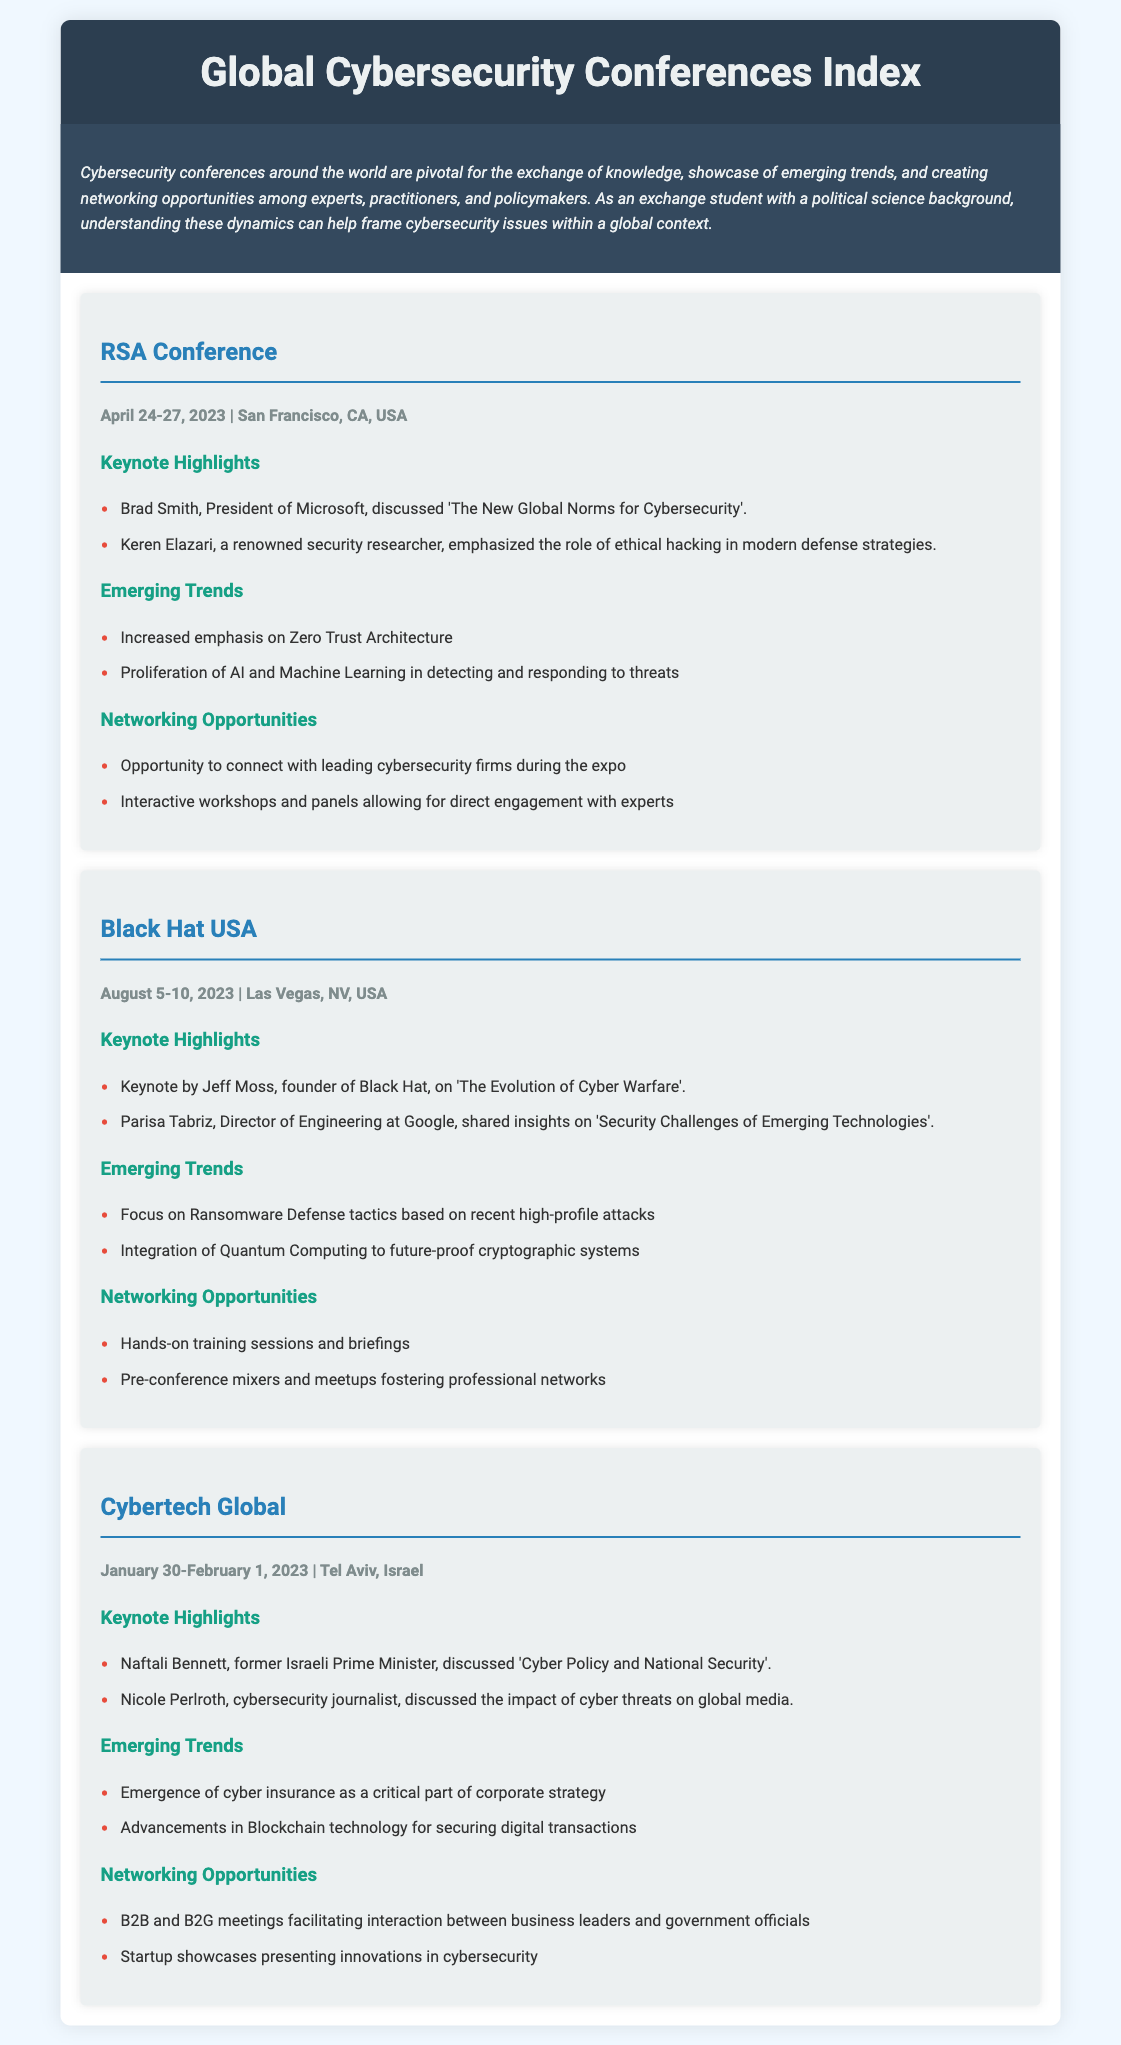What is the date of the RSA Conference? The date of the RSA Conference, as stated in the document, is April 24-27, 2023.
Answer: April 24-27, 2023 Who discussed 'Cyber Policy and National Security' at Cybertech Global? Naftali Bennett, the former Israeli Prime Minister, discussed 'Cyber Policy and National Security' at Cybertech Global.
Answer: Naftali Bennett Which conference took place in Tel Aviv, Israel? The document specifies that the Cybertech Global conference was held in Tel Aviv, Israel.
Answer: Cybertech Global What emerging trend was highlighted at Black Hat USA? The document mentions a focus on Ransomware Defense tactics based on recent high-profile attacks as an emerging trend at Black Hat USA.
Answer: Ransomware Defense tactics What type of networking opportunities were available at the RSA Conference? The document lists opportunities including connecting with leading cybersecurity firms and interacting with experts during workshops at the RSA Conference.
Answer: Connect with leading cybersecurity firms Who emphasized the role of ethical hacking at the RSA Conference? Keren Elazari emphasized the role of ethical hacking in modern defense strategies at the RSA Conference.
Answer: Keren Elazari How many keynote highlights are listed for the Black Hat USA conference? The document presents two keynote highlights for Black Hat USA: one by Jeff Moss and another by Parisa Tabriz.
Answer: Two What was discussed by Nicole Perlroth at Cybertech Global? Nicole Perlroth discussed the impact of cyber threats on global media at Cybertech Global.
Answer: Impact of cyber threats on global media 